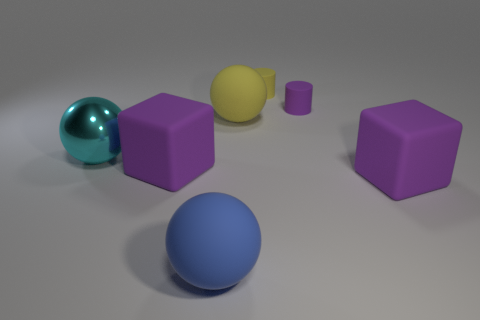Is there any indication of movement or dynamism in the scene? The image is still, with no explicit indicators of movement. The objects are stationary and there are no dynamic elements, like motion blur, to suggest movement. 